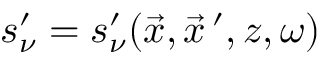Convert formula to latex. <formula><loc_0><loc_0><loc_500><loc_500>s _ { \nu } ^ { \prime } = s _ { \nu } ^ { \prime } ( \vec { x } , \vec { x } \, ^ { \prime } , z , \omega )</formula> 